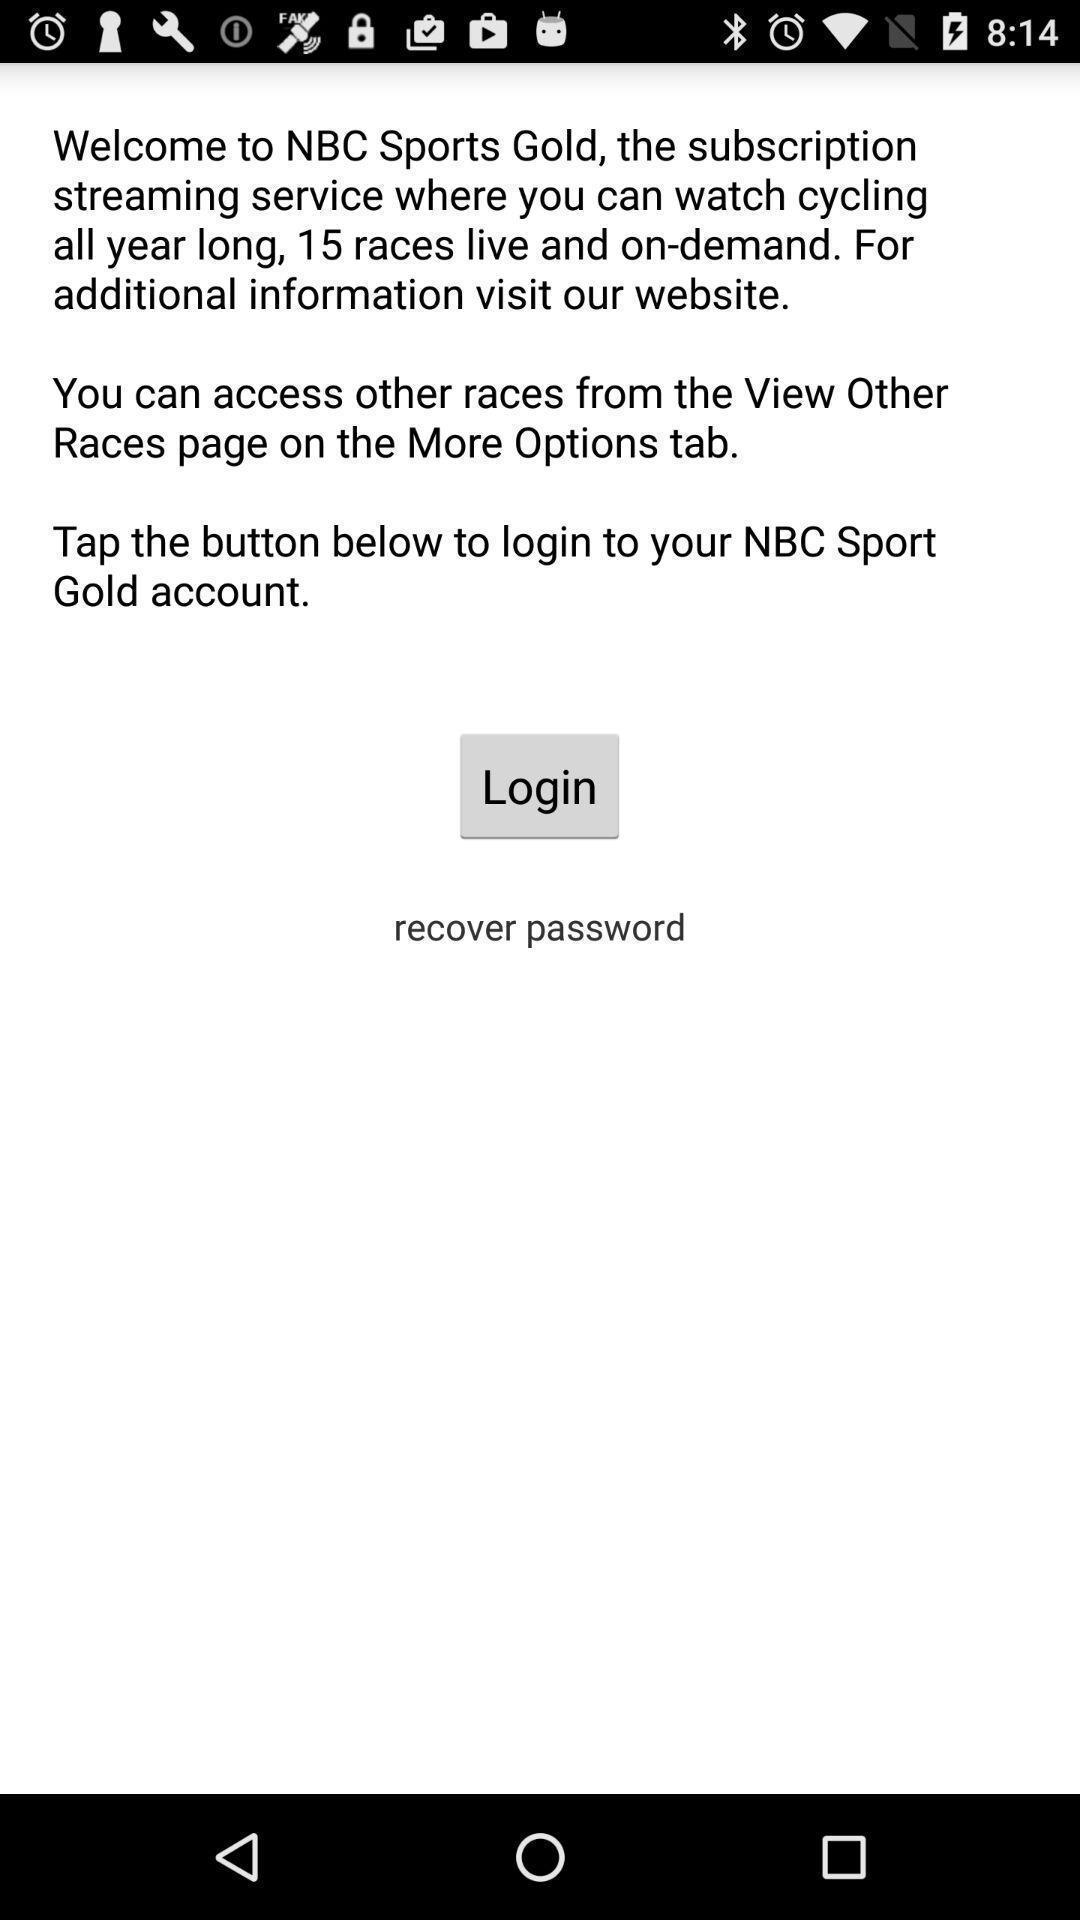What can you discern from this picture? Welcome and login page of sports application. 